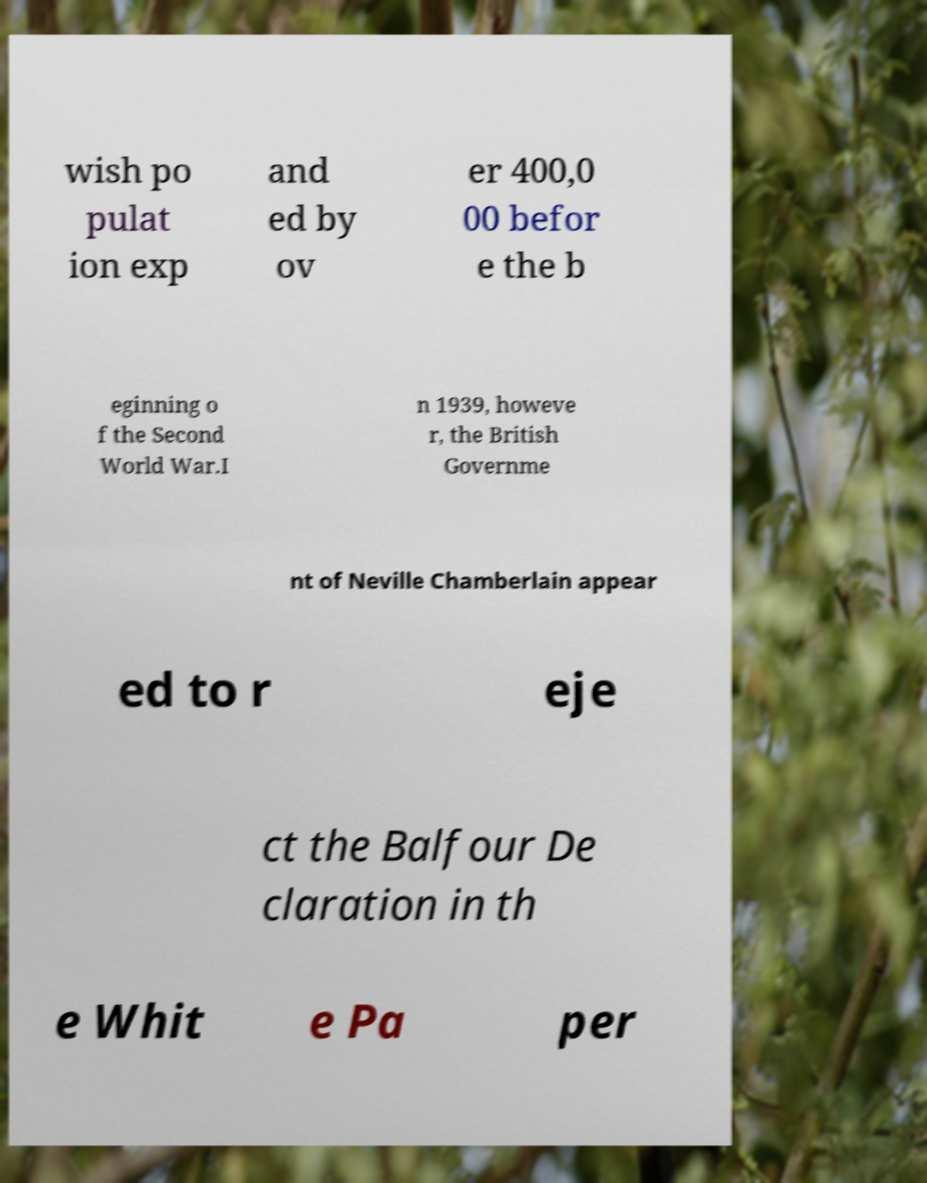What messages or text are displayed in this image? I need them in a readable, typed format. wish po pulat ion exp and ed by ov er 400,0 00 befor e the b eginning o f the Second World War.I n 1939, howeve r, the British Governme nt of Neville Chamberlain appear ed to r eje ct the Balfour De claration in th e Whit e Pa per 